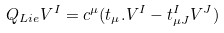Convert formula to latex. <formula><loc_0><loc_0><loc_500><loc_500>Q _ { L i e } V ^ { I } = c ^ { \mu } ( t _ { \mu } . V ^ { I } - t _ { \mu J } ^ { I } V ^ { J } )</formula> 